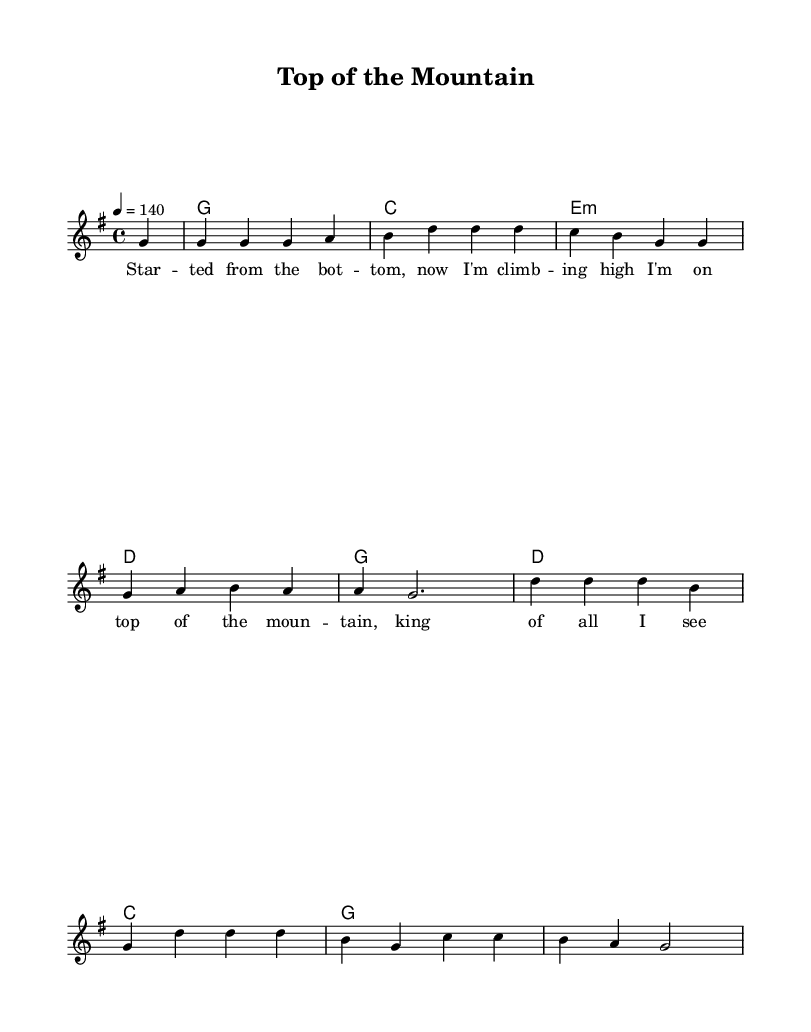What is the key signature of this music? The key signature is G major, which has one sharp (F#).
Answer: G major What is the time signature of the piece? The time signature is 4/4, indicating four beats per measure.
Answer: 4/4 What is the tempo marking for the piece? The tempo marking is 140 beats per minute, which is relatively fast and energetic.
Answer: 140 How many measures are in the melody? The melody section consists of eight measures, as counted from the start to the end of the melody part.
Answer: Eight measures What is the primary theme of the lyrics? The primary theme of the lyrics is about achieving success and feeling triumphant while at the top.
Answer: Achieving success Which chord appears most frequently in the harmonies? The G major chord appears most frequently, as it is repeated multiple times across the measures.
Answer: G What type of musical structure is used in this piece? This piece likely follows a verse-chorus structure common in country rock, focusing on storytelling about success.
Answer: Verse-chorus structure 